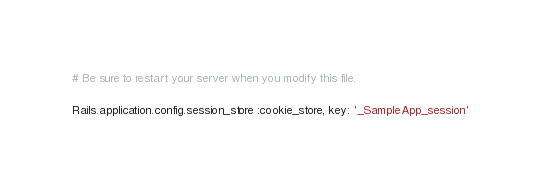Convert code to text. <code><loc_0><loc_0><loc_500><loc_500><_Ruby_># Be sure to restart your server when you modify this file.

Rails.application.config.session_store :cookie_store, key: '_SampleApp_session'
</code> 